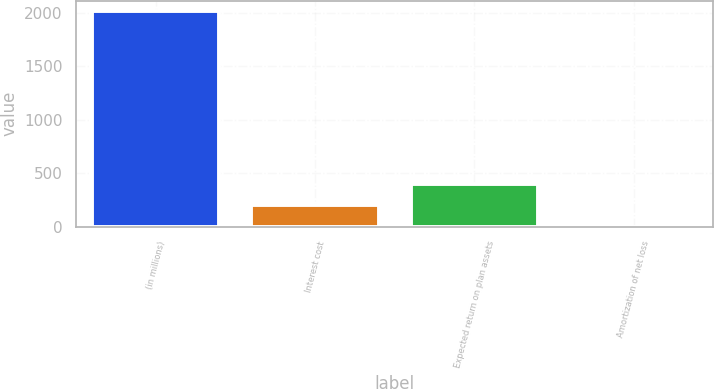<chart> <loc_0><loc_0><loc_500><loc_500><bar_chart><fcel>(in millions)<fcel>Interest cost<fcel>Expected return on plan assets<fcel>Amortization of net loss<nl><fcel>2014<fcel>202.3<fcel>403.6<fcel>1<nl></chart> 